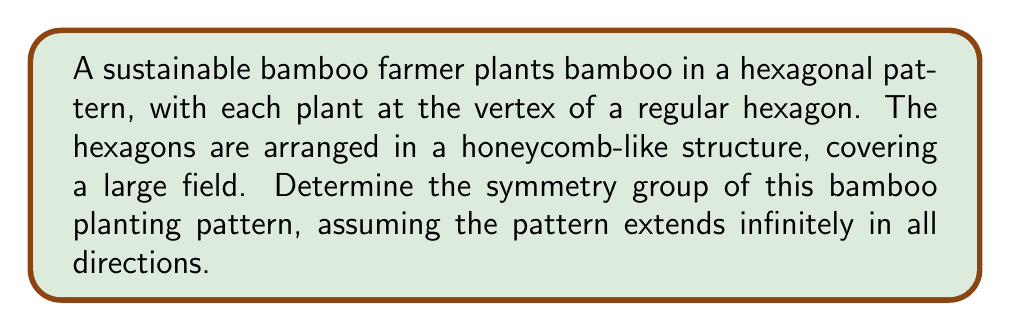Solve this math problem. To determine the symmetry group of this bamboo planting pattern, we need to consider all the transformations that leave the pattern unchanged. Let's approach this step-by-step:

1. Rotational symmetry:
   The pattern has 6-fold rotational symmetry around the center of each hexagon. This means rotations by multiples of 60° (or $\frac{\pi}{3}$ radians) leave the pattern unchanged.

2. Translational symmetry:
   The pattern can be translated in three directions, corresponding to the three axes of the hexagonal lattice. Let $\vec{a}$, $\vec{b}$, and $\vec{c}$ be the three basic translation vectors, where $\vec{c} = -(\vec{a} + \vec{b})$.

3. Reflectional symmetry:
   There are three axes of reflection through each hexagon center, bisecting opposite sides.

4. Glide reflection:
   The pattern also exhibits glide reflections, which are combinations of reflections and translations.

These symmetries correspond to the wallpaper group p6m, which is one of the 17 two-dimensional crystallographic groups.

The symmetry group can be generated by:
- A 60° rotation: $r$
- Two translations: $t_1$ and $t_2$
- A reflection: $s$

The group has the following presentation:
$$ \langle r, s, t_1, t_2 | r^6 = s^2 = (rs)^2 = e, [t_1, t_2] = e, rt_ir^{-1} = t_j \text{ for some } j, st_is^{-1} = t_k^{-1} \text{ for some } k \rangle $$

Where $e$ is the identity element, and $[t_1, t_2]$ denotes the commutator of $t_1$ and $t_2$.

This group is isomorphic to the semi-direct product of the translational subgroup (isomorphic to $\mathbb{Z}^2$) and the point group (isomorphic to the dihedral group $D_6$):

$$ p6m \cong \mathbb{Z}^2 \rtimes D_6 $$
Answer: $p6m \cong \mathbb{Z}^2 \rtimes D_6$ 